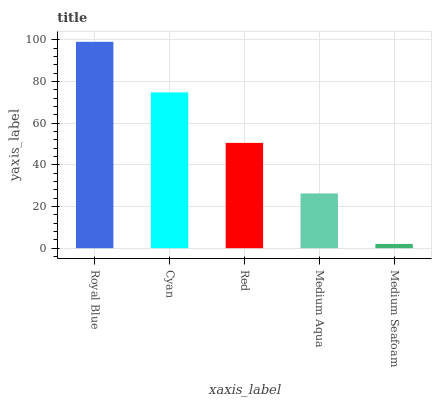Is Medium Seafoam the minimum?
Answer yes or no. Yes. Is Royal Blue the maximum?
Answer yes or no. Yes. Is Cyan the minimum?
Answer yes or no. No. Is Cyan the maximum?
Answer yes or no. No. Is Royal Blue greater than Cyan?
Answer yes or no. Yes. Is Cyan less than Royal Blue?
Answer yes or no. Yes. Is Cyan greater than Royal Blue?
Answer yes or no. No. Is Royal Blue less than Cyan?
Answer yes or no. No. Is Red the high median?
Answer yes or no. Yes. Is Red the low median?
Answer yes or no. Yes. Is Medium Aqua the high median?
Answer yes or no. No. Is Cyan the low median?
Answer yes or no. No. 